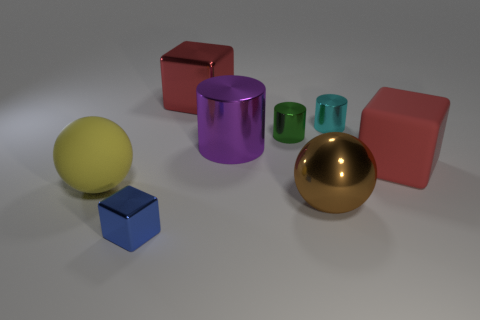Which is the largest object and what is its color and material? The largest object in the image is the golden sphere which appears to be made of metal due to its reflective surface. Its color is a shiny gold, which stands out against the more matte colors of the other objects. 